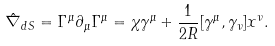Convert formula to latex. <formula><loc_0><loc_0><loc_500><loc_500>\hat { \nabla } _ { d S } = \Gamma ^ { \mu } \partial _ { \mu } \Gamma ^ { \mu } = \chi \gamma ^ { \mu } + \frac { 1 } { 2 R } [ \gamma ^ { \mu } , \gamma _ { \nu } ] x ^ { \nu } .</formula> 